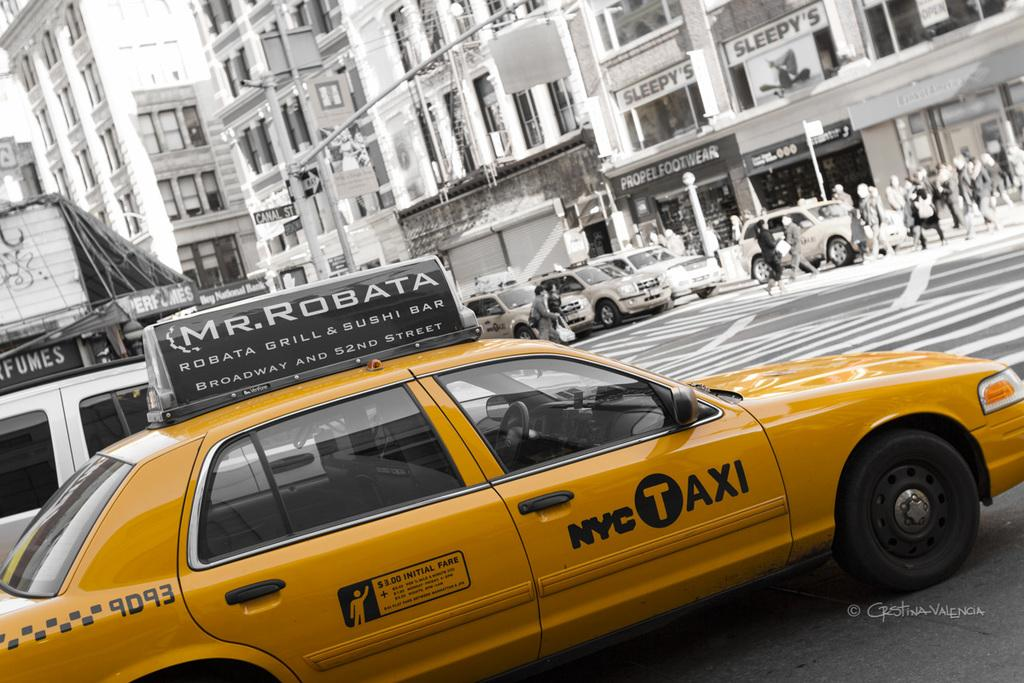<image>
Provide a brief description of the given image. A yellow four door sedan is a NYC taxi. 